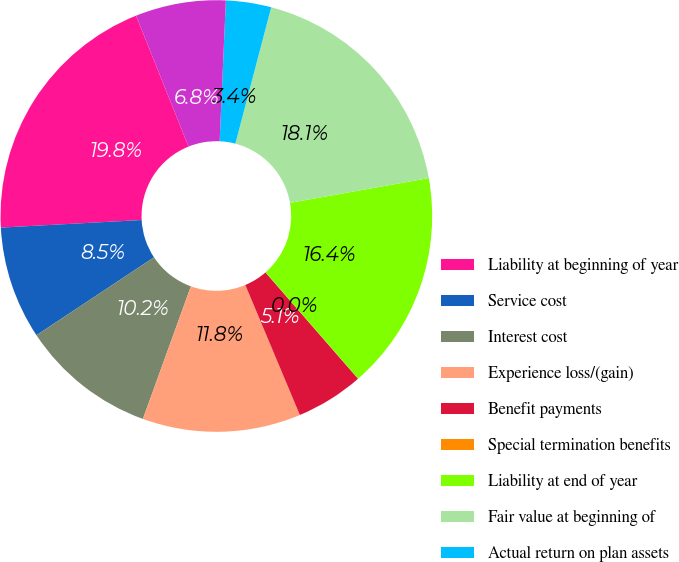Convert chart. <chart><loc_0><loc_0><loc_500><loc_500><pie_chart><fcel>Liability at beginning of year<fcel>Service cost<fcel>Interest cost<fcel>Experience loss/(gain)<fcel>Benefit payments<fcel>Special termination benefits<fcel>Liability at end of year<fcel>Fair value at beginning of<fcel>Actual return on plan assets<fcel>Employer contributions/funding<nl><fcel>19.79%<fcel>8.46%<fcel>10.16%<fcel>11.85%<fcel>5.08%<fcel>0.01%<fcel>16.4%<fcel>18.1%<fcel>3.39%<fcel>6.77%<nl></chart> 